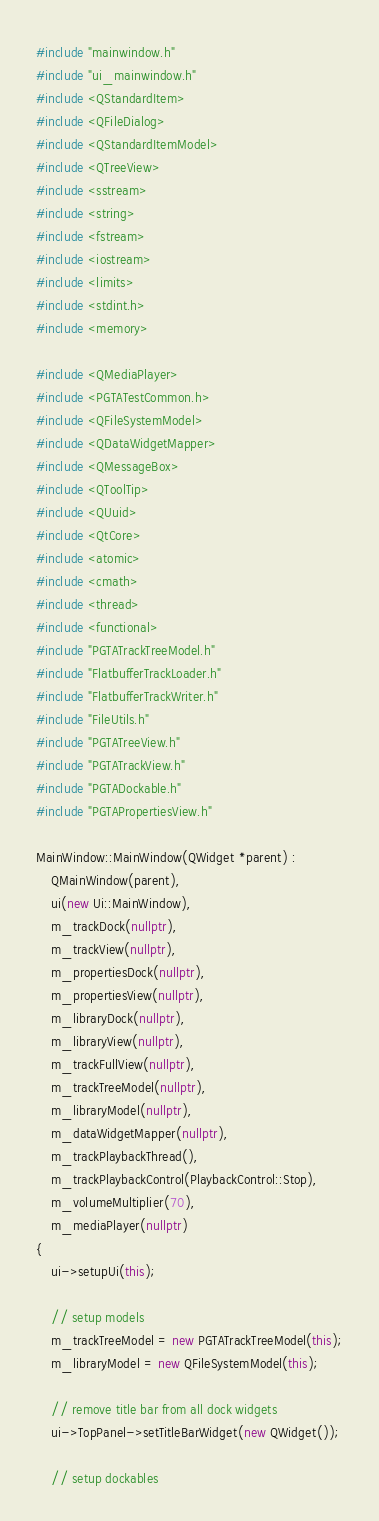Convert code to text. <code><loc_0><loc_0><loc_500><loc_500><_C++_>#include "mainwindow.h"
#include "ui_mainwindow.h"
#include <QStandardItem>
#include <QFileDialog>
#include <QStandardItemModel>
#include <QTreeView>
#include <sstream>
#include <string>
#include <fstream>
#include <iostream>
#include <limits>
#include <stdint.h>
#include <memory>

#include <QMediaPlayer>
#include <PGTATestCommon.h>
#include <QFileSystemModel>
#include <QDataWidgetMapper>
#include <QMessageBox>
#include <QToolTip>
#include <QUuid>
#include <QtCore>
#include <atomic>
#include <cmath>
#include <thread>
#include <functional>
#include "PGTATrackTreeModel.h"
#include "FlatbufferTrackLoader.h"
#include "FlatbufferTrackWriter.h"
#include "FileUtils.h"
#include "PGTATreeView.h"
#include "PGTATrackView.h"
#include "PGTADockable.h"
#include "PGTAPropertiesView.h"

MainWindow::MainWindow(QWidget *parent) :
    QMainWindow(parent),
    ui(new Ui::MainWindow),
    m_trackDock(nullptr),
    m_trackView(nullptr),
    m_propertiesDock(nullptr),
    m_propertiesView(nullptr),
    m_libraryDock(nullptr),
    m_libraryView(nullptr),
    m_trackFullView(nullptr),
    m_trackTreeModel(nullptr),
    m_libraryModel(nullptr),
    m_dataWidgetMapper(nullptr),
    m_trackPlaybackThread(),
    m_trackPlaybackControl(PlaybackControl::Stop),
    m_volumeMultiplier(70),
    m_mediaPlayer(nullptr)
{
    ui->setupUi(this);

    // setup models
    m_trackTreeModel = new PGTATrackTreeModel(this);
    m_libraryModel = new QFileSystemModel(this);

    // remove title bar from all dock widgets
    ui->TopPanel->setTitleBarWidget(new QWidget());

    // setup dockables</code> 